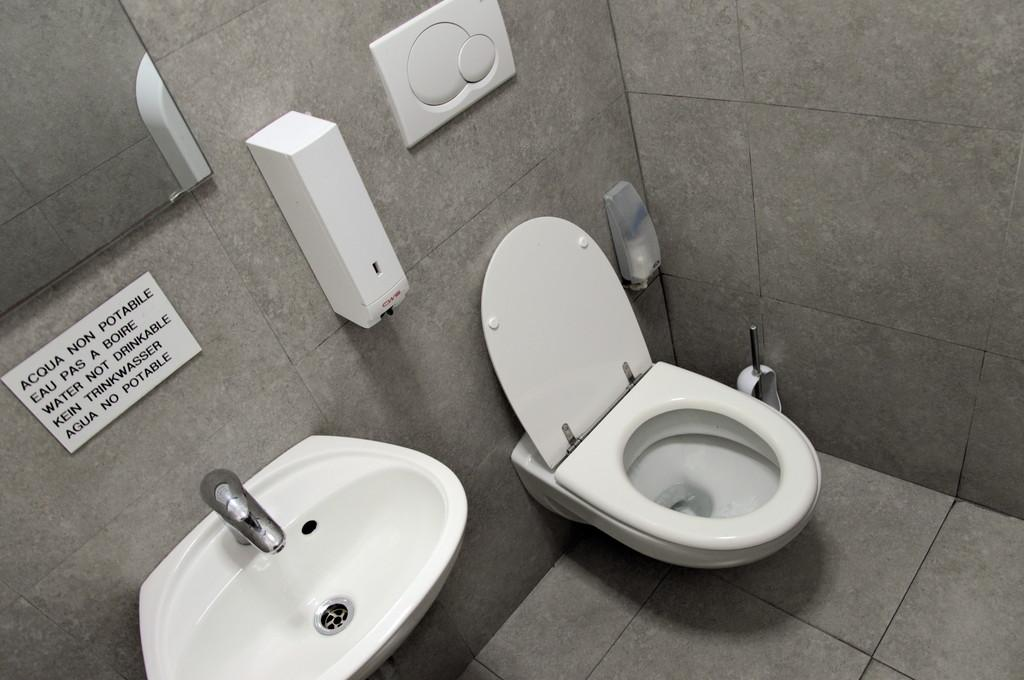What type of toilet is visible in the image? There is a western toilet in the image. What is located on the wall near the toilet? There is a sink with a tap and a mirror on the wall in the image. What else can be seen on the wall in the image? There are boxes present on the wall in the image. How many sisters are sitting on the throne in the image? There is no throne or sisters present in the image. What type of jewelry is the person wearing in the image? There is no person or jewelry visible in the image. 